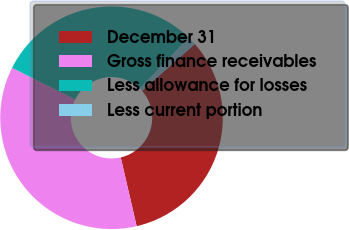Convert chart. <chart><loc_0><loc_0><loc_500><loc_500><pie_chart><fcel>December 31<fcel>Gross finance receivables<fcel>Less allowance for losses<fcel>Less current portion<nl><fcel>32.91%<fcel>36.03%<fcel>29.8%<fcel>1.26%<nl></chart> 